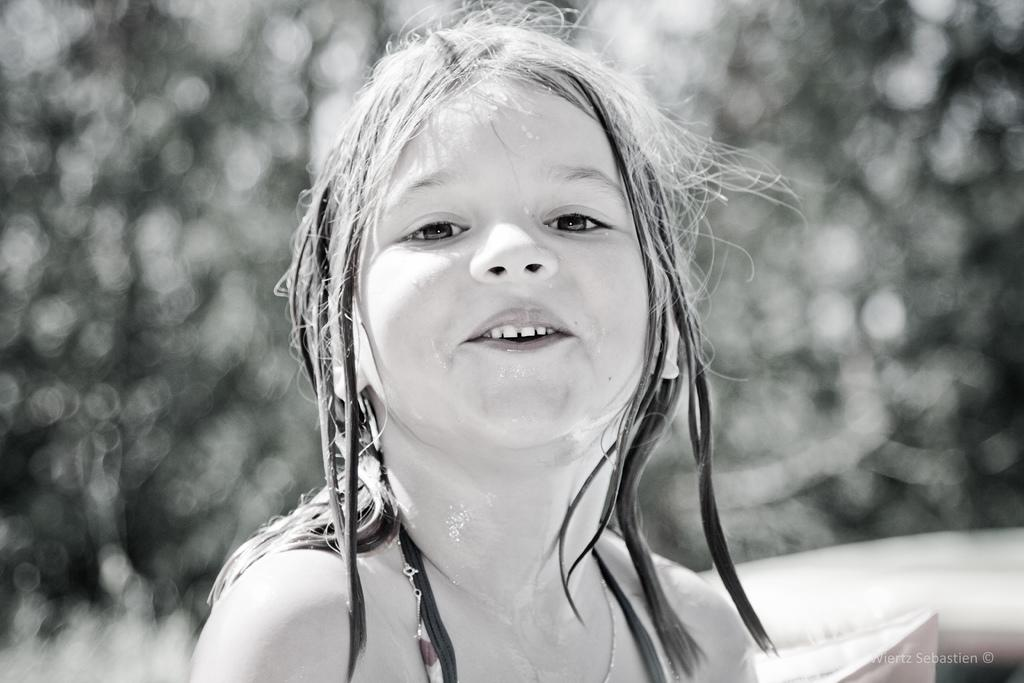Who is the main subject in the picture? There is a girl in the picture. Is there any text or logo visible in the image? Yes, there is a watermark at the bottom right corner of the picture. How would you describe the background of the picture? The background of the picture appears blurry. What type of religious symbol can be seen in the picture? There is no religious symbol present in the image. How many cats are visible in the picture? There are no cats present in the image. 